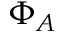<formula> <loc_0><loc_0><loc_500><loc_500>\Phi _ { A }</formula> 